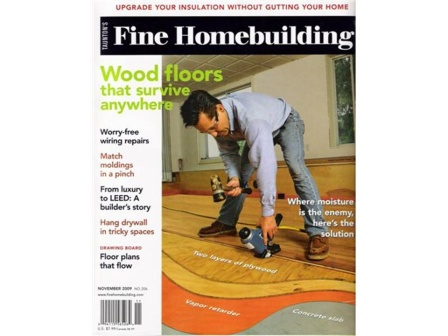If you were to imagine a whimsical story about the man on the cover, what might his day-to-day life be like? In a whimsical twist, the man on the cover could be a modern-day artisan named Jack, who lives in a charming, self-made cottage in the woods, where every piece of furniture and fixture tells a story. Jack's day begins at the break of dawn, greeted by birds that chirp melodious tunes as he steps out into his lush garden to fetch fresh herbs. His mornings are filled with the aroma of freshly brewed coffee and the satisfaction of chipping away at his latest woodworking project. As word of his extraordinary skills spreads, people from nearby towns often seek his help with peculiar requests, like crafting a staircase that leads to a hidden attic or repairing an ancient rocking chair inherited from a great-grandparent. At sunset, Jack can be seen at his porch, sharing tales of his creations by a warm fire, under a sky full of stars. 